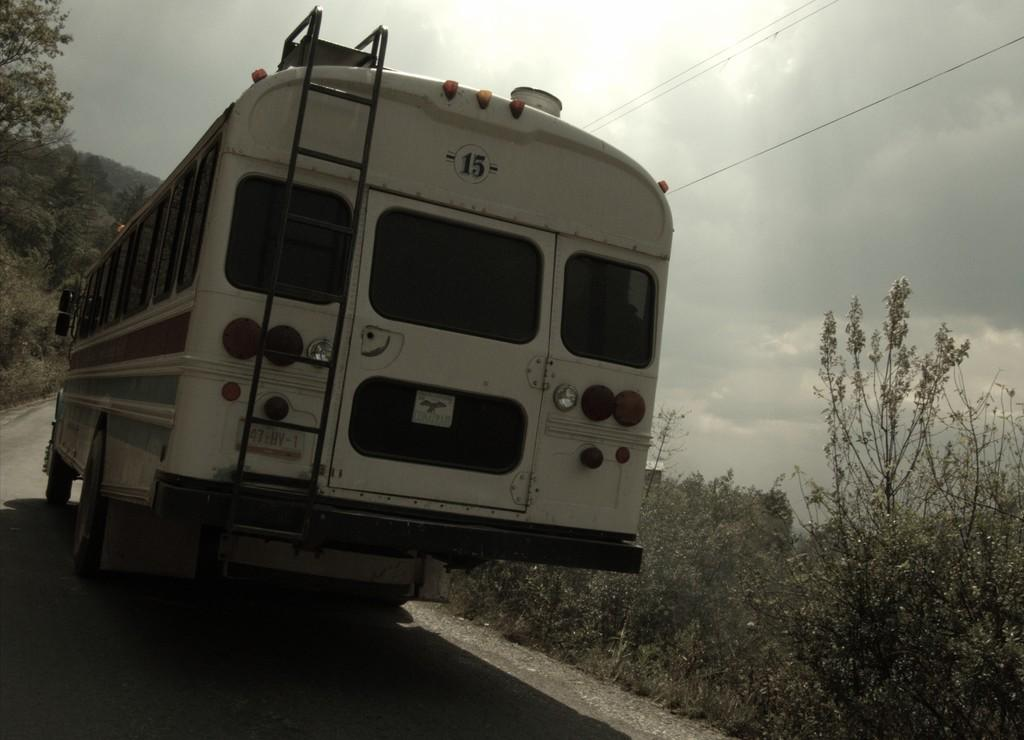What is the main subject in the foreground of the image? There is a bus in the foreground of the image. What is the bus doing in the image? The bus is moving on the road. What can be seen on either side of the road in the image? There are trees on either side of the road. What is visible at the top of the image? The sky is visible at the top of the image. What else can be seen in the image besides the bus and trees? Cables are present in the image. What is the condition of the sky in the image? The sun is visible in the sky. Can you tell me how many tents are set up along the road in the image? There are no tents present in the image; it features a moving bus on a road with trees and cables. What type of ornament is hanging from the bus in the image? There is no ornament hanging from the bus in the image; it is a regular bus moving on the road. 